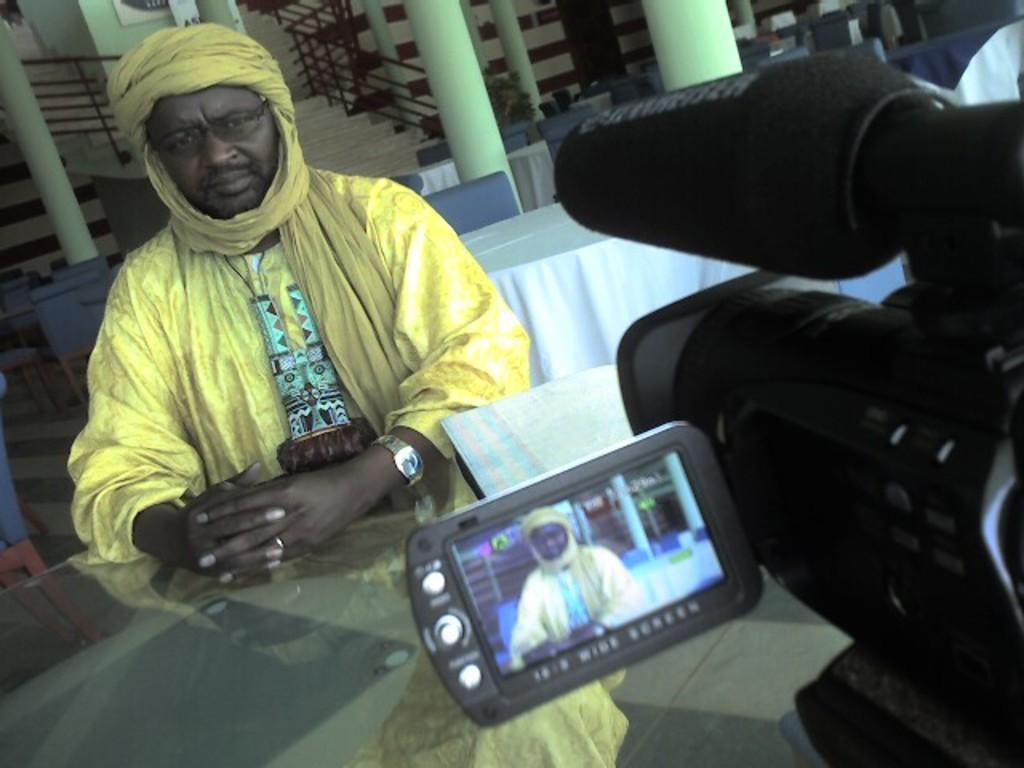How would you summarize this image in a sentence or two? In this image we can see a man is sitting. He is wearing yellow color dress. In front of him glass table is there. And on table camera and one thing is present. Behind the men tables and chairs are present. Top of the image pillars and stairs are there. 